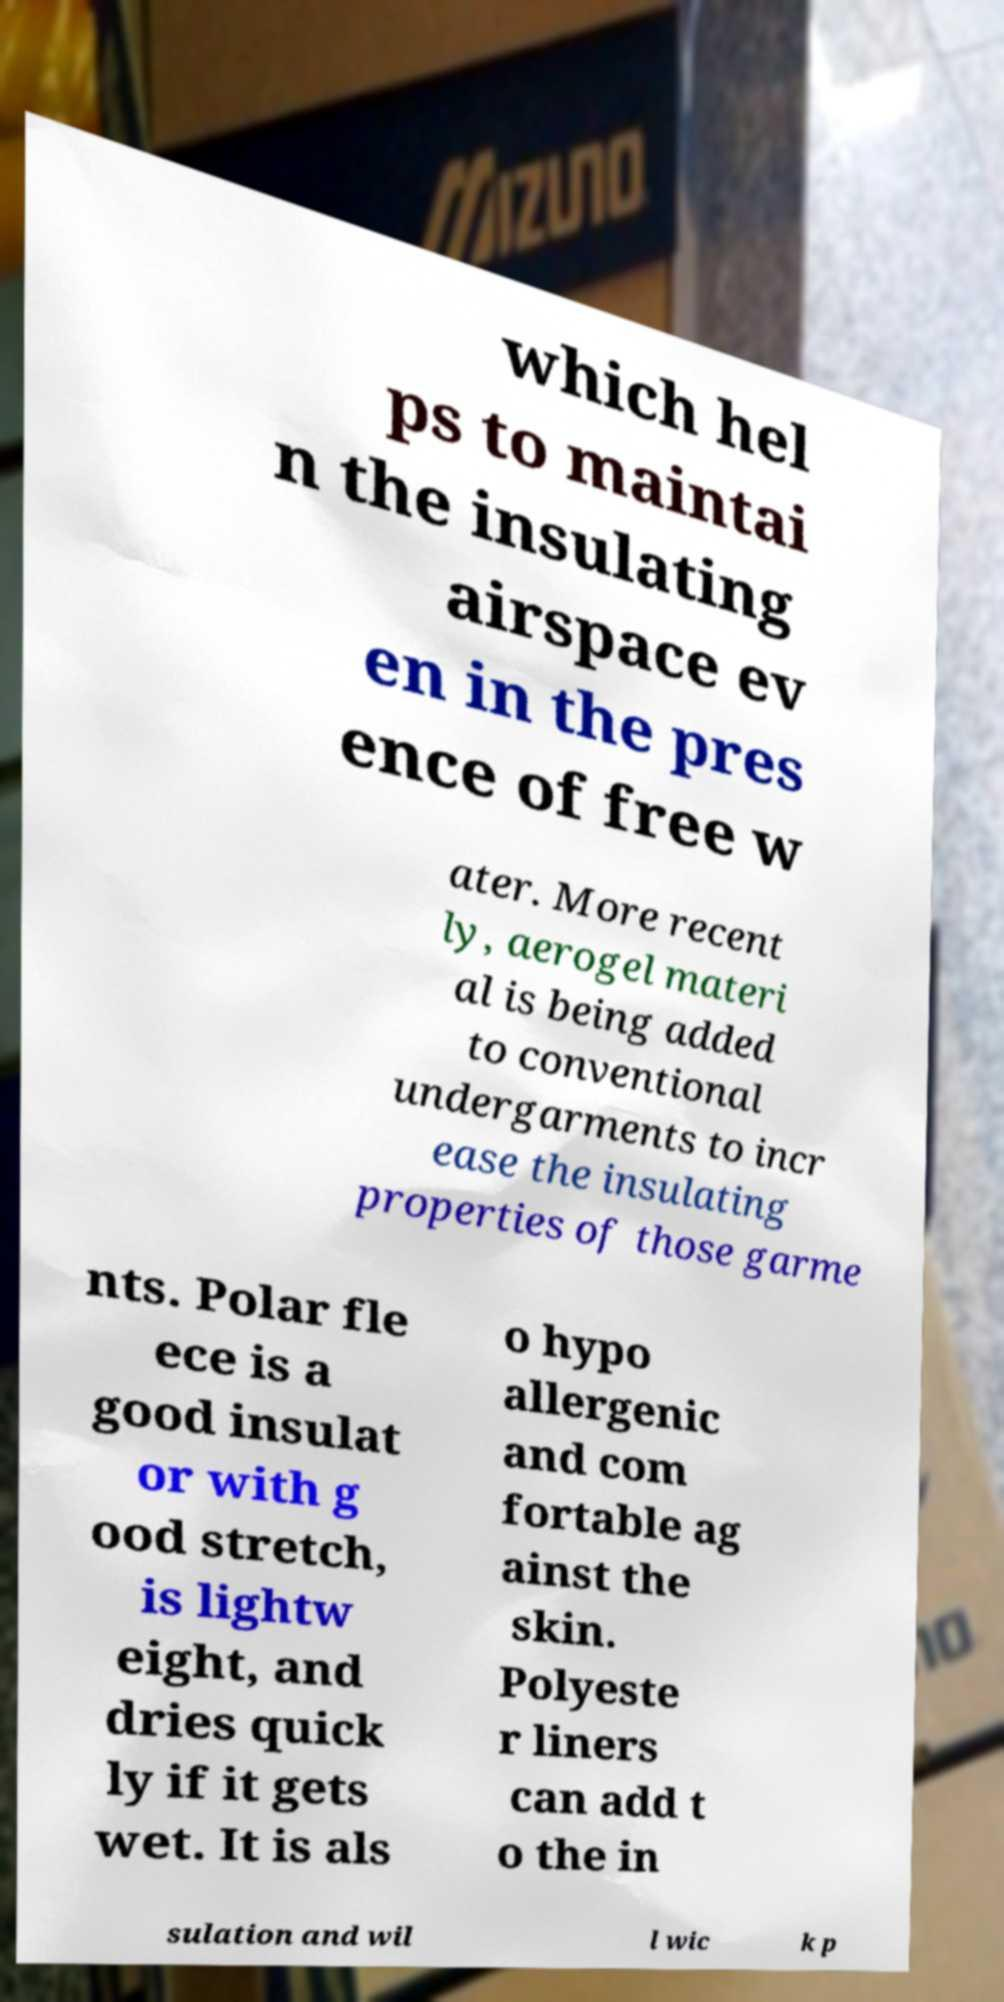Could you assist in decoding the text presented in this image and type it out clearly? which hel ps to maintai n the insulating airspace ev en in the pres ence of free w ater. More recent ly, aerogel materi al is being added to conventional undergarments to incr ease the insulating properties of those garme nts. Polar fle ece is a good insulat or with g ood stretch, is lightw eight, and dries quick ly if it gets wet. It is als o hypo allergenic and com fortable ag ainst the skin. Polyeste r liners can add t o the in sulation and wil l wic k p 